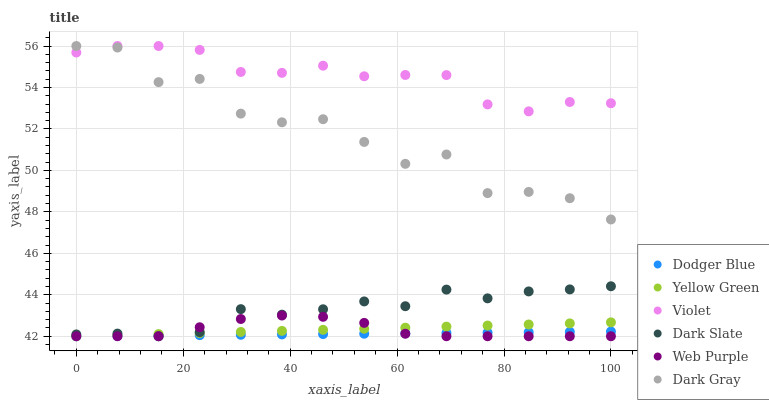Does Dodger Blue have the minimum area under the curve?
Answer yes or no. Yes. Does Violet have the maximum area under the curve?
Answer yes or no. Yes. Does Dark Gray have the minimum area under the curve?
Answer yes or no. No. Does Dark Gray have the maximum area under the curve?
Answer yes or no. No. Is Dodger Blue the smoothest?
Answer yes or no. Yes. Is Dark Gray the roughest?
Answer yes or no. Yes. Is Dark Slate the smoothest?
Answer yes or no. No. Is Dark Slate the roughest?
Answer yes or no. No. Does Yellow Green have the lowest value?
Answer yes or no. Yes. Does Dark Gray have the lowest value?
Answer yes or no. No. Does Violet have the highest value?
Answer yes or no. Yes. Does Dark Slate have the highest value?
Answer yes or no. No. Is Dark Slate less than Dark Gray?
Answer yes or no. Yes. Is Dark Gray greater than Web Purple?
Answer yes or no. Yes. Does Dodger Blue intersect Web Purple?
Answer yes or no. Yes. Is Dodger Blue less than Web Purple?
Answer yes or no. No. Is Dodger Blue greater than Web Purple?
Answer yes or no. No. Does Dark Slate intersect Dark Gray?
Answer yes or no. No. 